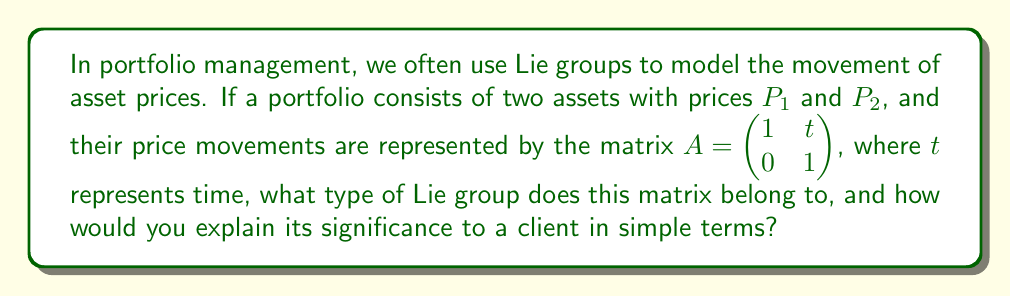What is the answer to this math problem? To answer this question, let's break it down into steps:

1) First, we need to identify the type of matrix we're dealing with. The matrix $A = \begin{pmatrix} 1 & t \\ 0 & 1 \end{pmatrix}$ is an upper triangular matrix with 1's on the diagonal. This is a special type of matrix known as a unipotent matrix.

2) The set of all such matrices forms a Lie group called the "Heisenberg group". This group is named after Werner Heisenberg, a physicist who used similar structures in quantum mechanics.

3) In the context of portfolio management, this Lie group models a specific type of price movement:
   
   - The diagonal elements being 1 indicate that the individual asset prices remain stable over time.
   - The upper right element $t$ represents a linear drift or trend in the relationship between the two assets over time.

4) To explain this to a client in simple terms, we could say:

   "Imagine we have two investments, like stocks and bonds. The Heisenberg group helps us model a situation where the prices of these investments don't change much on their own, but their relationship to each other changes smoothly over time. It's like two boats floating side by side - they might not move up or down much, but the distance between them could gradually increase or decrease."

5) The significance of this in portfolio management is that it allows us to model and potentially predict how the relationship between assets might evolve over time, even if the individual asset prices remain relatively stable. This can be crucial for strategies that rely on the relative performance of different assets, such as pairs trading or certain types of arbitrage.
Answer: The matrix belongs to the Heisenberg group, a type of Lie group. Its significance in portfolio management is that it models a situation where individual asset prices remain stable, but their relationship evolves linearly over time, which is useful for strategies relying on relative asset performance. 